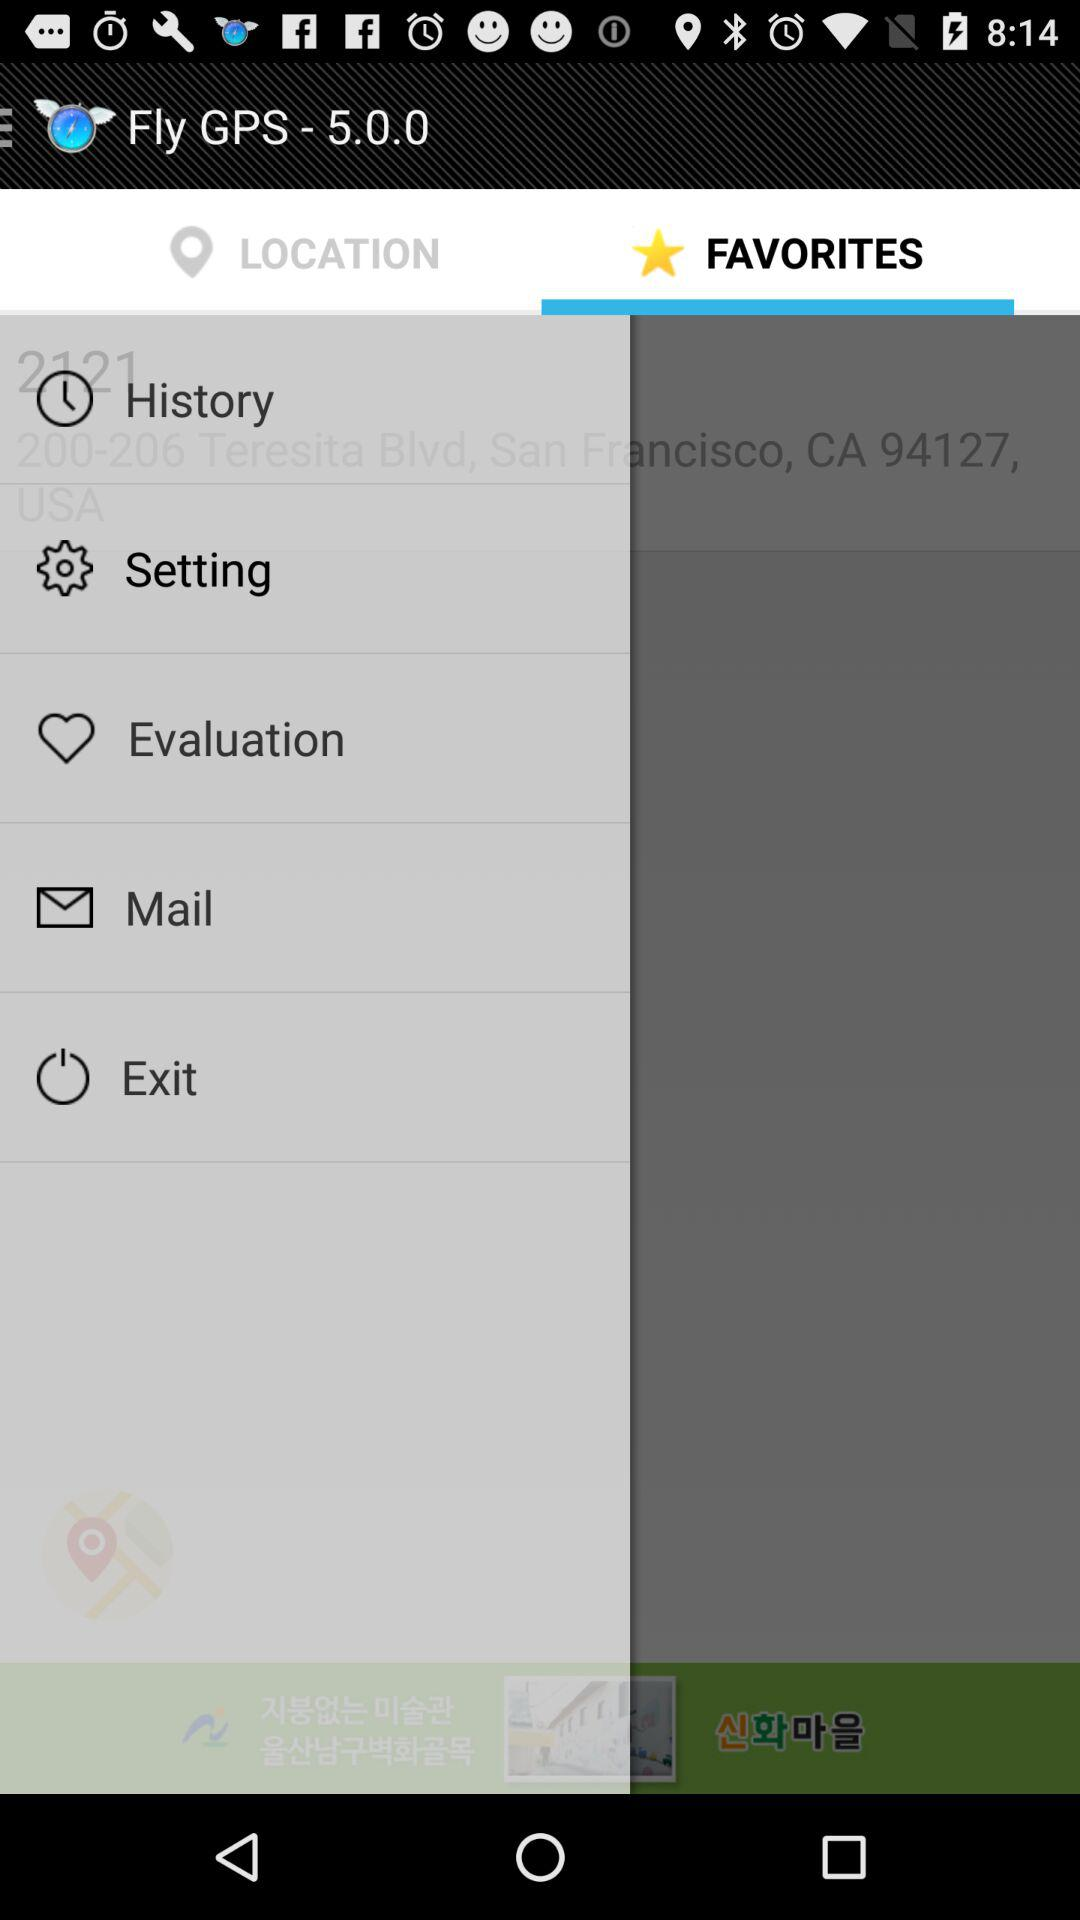Which tab is selected? The selected tab is "FAVORITES". 